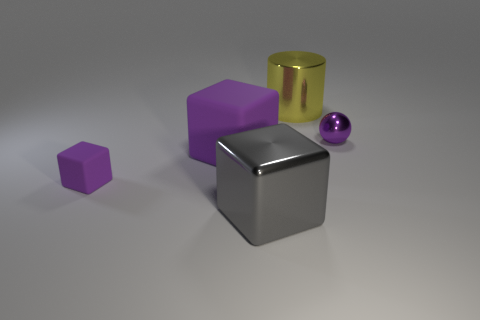Subtract all red spheres. Subtract all brown cylinders. How many spheres are left? 1 Add 4 shiny balls. How many objects exist? 9 Subtract all balls. How many objects are left? 4 Subtract all large gray things. Subtract all tiny purple shiny balls. How many objects are left? 3 Add 4 yellow objects. How many yellow objects are left? 5 Add 2 gray objects. How many gray objects exist? 3 Subtract 2 purple blocks. How many objects are left? 3 